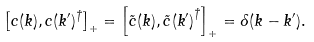<formula> <loc_0><loc_0><loc_500><loc_500>\left [ c ( k ) , c ( k ^ { \prime } ) ^ { \dagger } \right ] _ { + } = \left [ \tilde { c } ( k ) , \tilde { c } { ( k ^ { \prime } ) } ^ { \dagger } \right ] _ { + } = \delta ( k - { k ^ { \prime } } ) .</formula> 